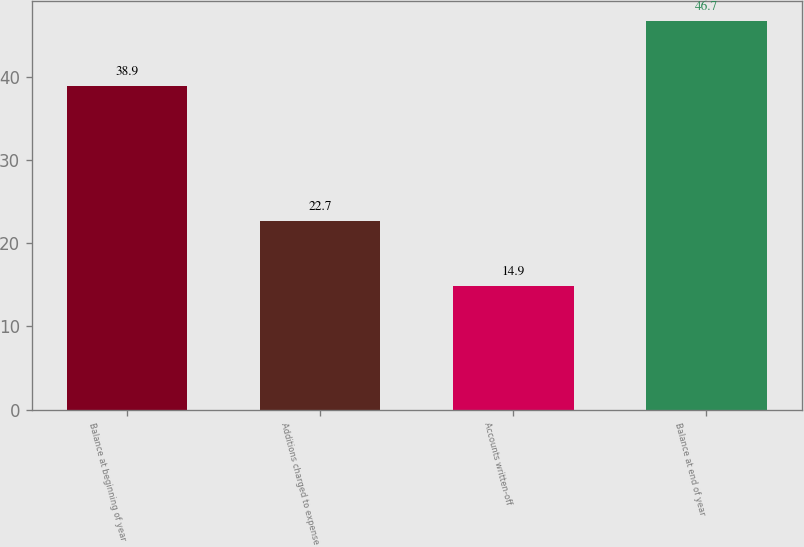Convert chart to OTSL. <chart><loc_0><loc_0><loc_500><loc_500><bar_chart><fcel>Balance at beginning of year<fcel>Additions charged to expense<fcel>Accounts written-off<fcel>Balance at end of year<nl><fcel>38.9<fcel>22.7<fcel>14.9<fcel>46.7<nl></chart> 